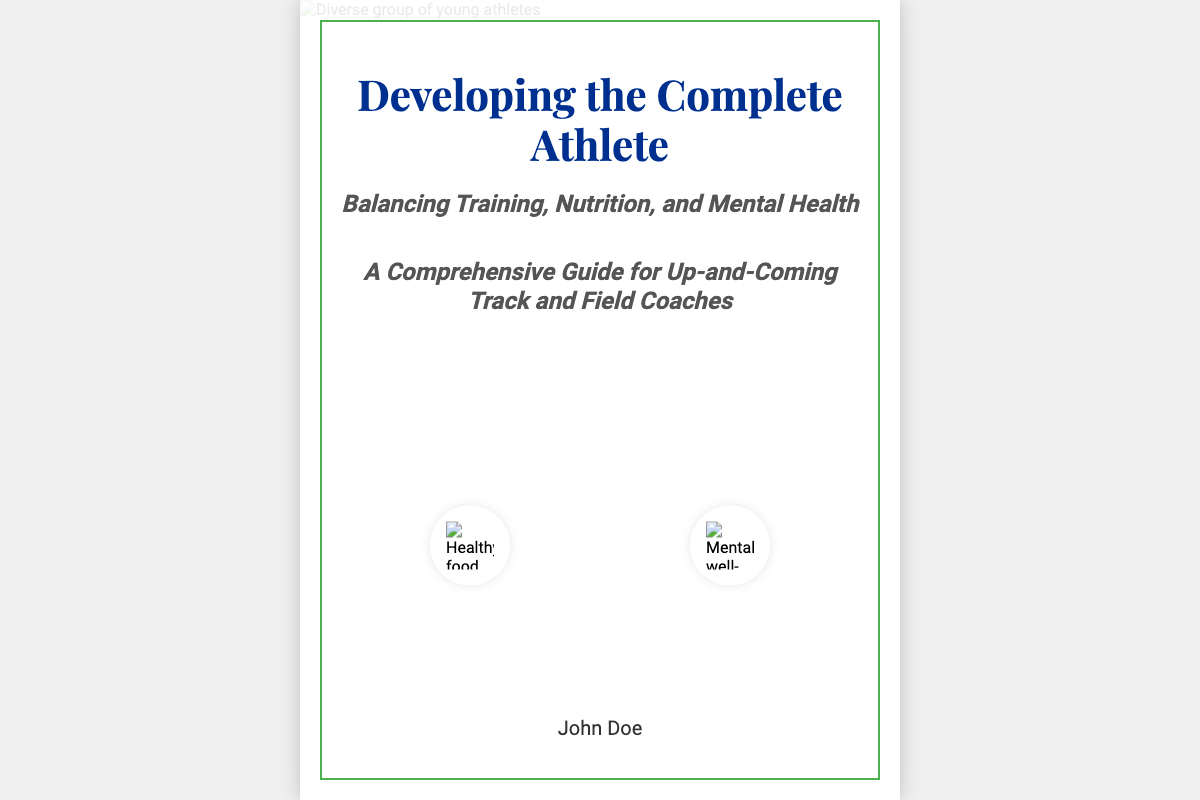What is the title of the book? The title of the book is prominently displayed at the top of the cover.
Answer: Developing the Complete Athlete Who is the author of the book? The author's name is located at the bottom of the cover.
Answer: John Doe What are the main topics balanced in the book? The subtitle highlights the key areas covered within the book.
Answer: Training, Nutrition, and Mental Health How many icons are displayed on the cover? Two icons representing healthy food and mental well-being are shown in the design.
Answer: Two What color is the accent border surrounding the book cover? The accent border color is specified in the design description.
Answer: Green What is the style of the book guide aimed at? The subtitle indicates the primary target audience for the book.
Answer: Up-and-Coming Track and Field Coaches What imagery is used to represent the athletes? The cover features a specific type of image to represent diversity.
Answer: Diverse group of young athletes What visual theme is emphasized in the cover design? The overall design focuses on a particular concept related to athlete development.
Answer: Balance 